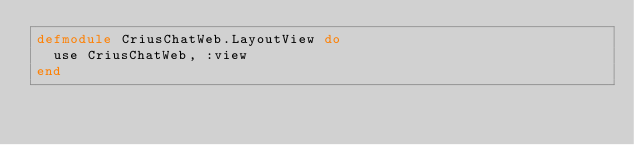Convert code to text. <code><loc_0><loc_0><loc_500><loc_500><_Elixir_>defmodule CriusChatWeb.LayoutView do
  use CriusChatWeb, :view
end
</code> 